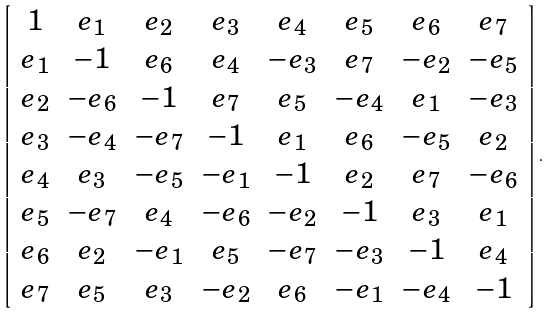Convert formula to latex. <formula><loc_0><loc_0><loc_500><loc_500>\left [ \begin{array} { c c c c c c c c } 1 & e _ { 1 } & e _ { 2 } & e _ { 3 } & e _ { 4 } & e _ { 5 } & e _ { 6 } & e _ { 7 } \\ e _ { 1 } & - 1 & e _ { 6 } & e _ { 4 } & - e _ { 3 } & e _ { 7 } & - e _ { 2 } & - e _ { 5 } \\ e _ { 2 } & - e _ { 6 } & - 1 & e _ { 7 } & e _ { 5 } & - e _ { 4 } & e _ { 1 } & - e _ { 3 } \\ e _ { 3 } & - e _ { 4 } & - e _ { 7 } & - 1 & e _ { 1 } & e _ { 6 } & - e _ { 5 } & e _ { 2 } \\ e _ { 4 } & e _ { 3 } & - e _ { 5 } & - e _ { 1 } & - 1 & e _ { 2 } & e _ { 7 } & - e _ { 6 } \\ e _ { 5 } & - e _ { 7 } & e _ { 4 } & - e _ { 6 } & - e _ { 2 } & - 1 & e _ { 3 } & e _ { 1 } \\ e _ { 6 } & e _ { 2 } & - e _ { 1 } & e _ { 5 } & - e _ { 7 } & - e _ { 3 } & - 1 & e _ { 4 } \\ e _ { 7 } & e _ { 5 } & e _ { 3 } & - e _ { 2 } & e _ { 6 } & - e _ { 1 } & - e _ { 4 } & - 1 \\ \end{array} \right ] .</formula> 